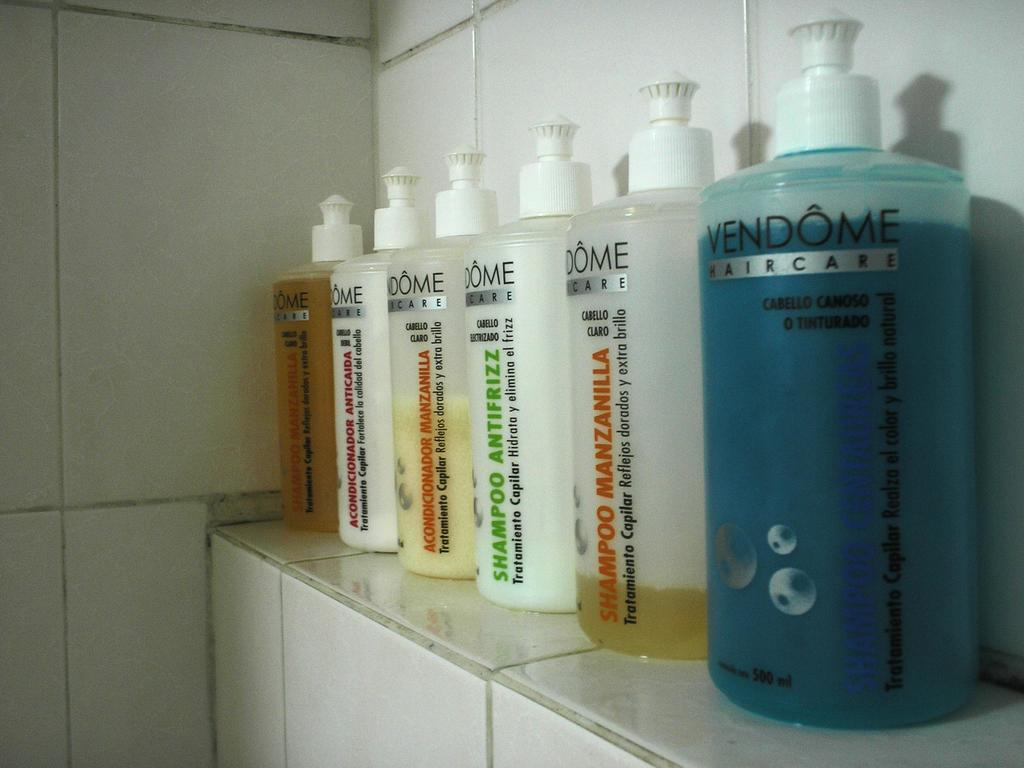<image>
Describe the image concisely. Six bottles of different color shampoo from the VENDOME brand. 